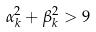Convert formula to latex. <formula><loc_0><loc_0><loc_500><loc_500>\alpha _ { k } ^ { 2 } + \beta _ { k } ^ { 2 } > 9</formula> 